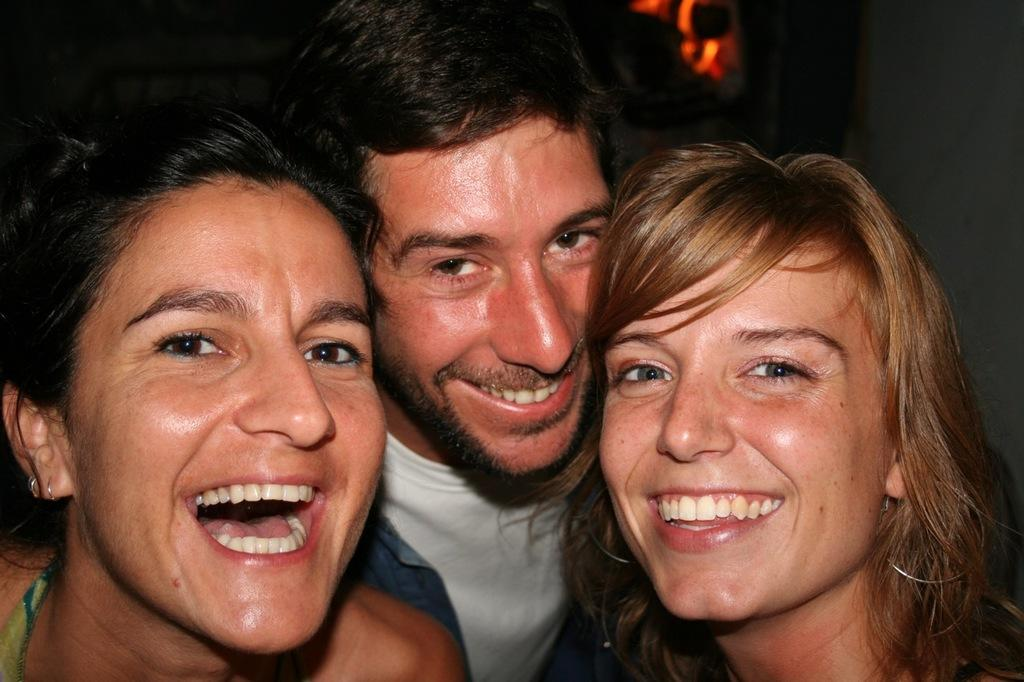Who or what is present in the image? There are people in the image. What are the people doing in the image? The people are laughing. Where are the people located in the image? The people are in the foreground area of the image. What type of fish can be seen swimming in the pan in the image? There is no fish or pan present in the image; it features people laughing in the foreground. 